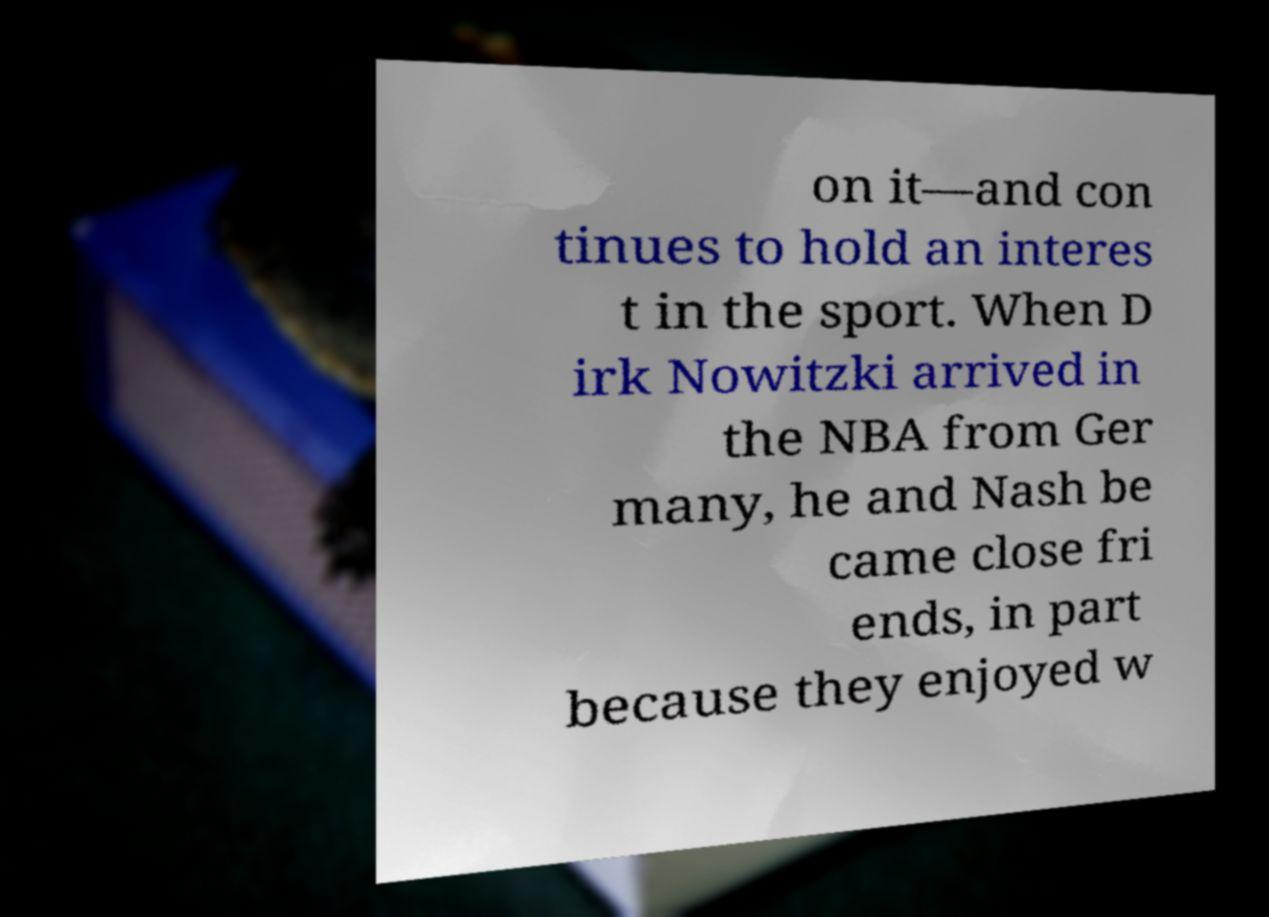What messages or text are displayed in this image? I need them in a readable, typed format. on it—and con tinues to hold an interes t in the sport. When D irk Nowitzki arrived in the NBA from Ger many, he and Nash be came close fri ends, in part because they enjoyed w 